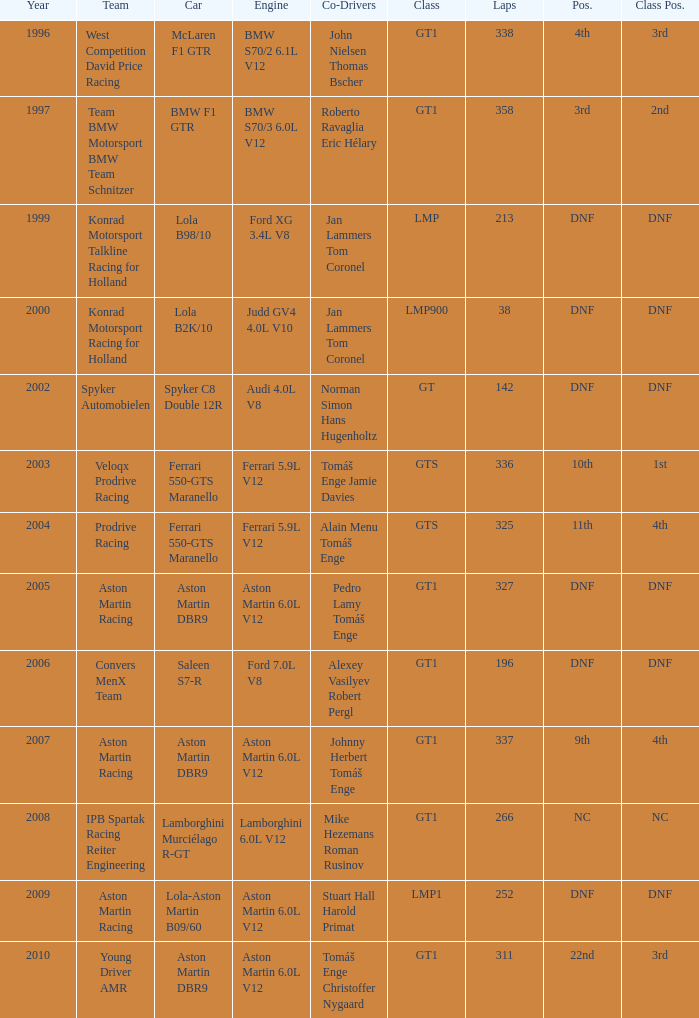Which position finished 3rd in class and completed less than 338 laps? 22nd. 